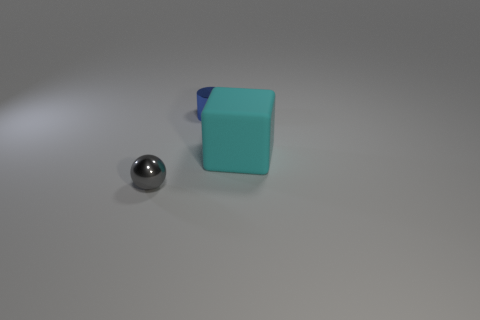Add 1 blue shiny cylinders. How many objects exist? 4 Subtract all cylinders. How many objects are left? 2 Subtract 0 cyan cylinders. How many objects are left? 3 Subtract all tiny gray cylinders. Subtract all cyan things. How many objects are left? 2 Add 2 blue metallic objects. How many blue metallic objects are left? 3 Add 3 rubber cubes. How many rubber cubes exist? 4 